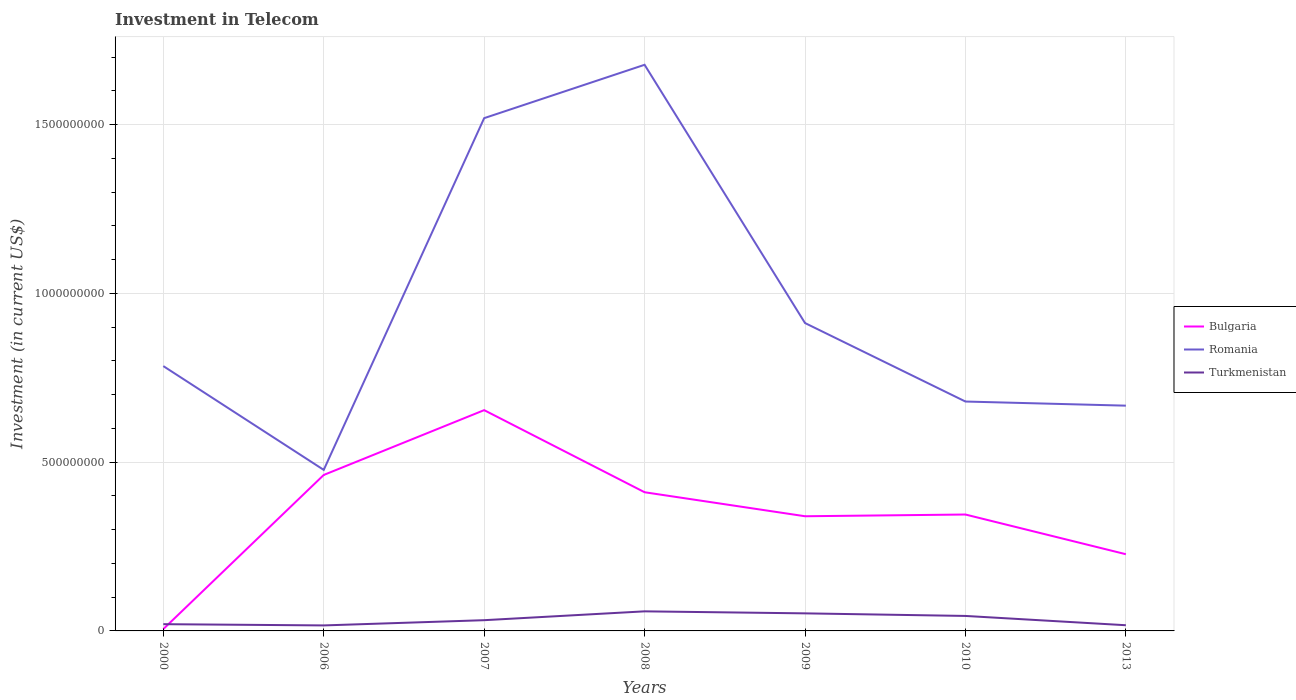How many different coloured lines are there?
Provide a short and direct response. 3. Does the line corresponding to Bulgaria intersect with the line corresponding to Turkmenistan?
Your answer should be very brief. Yes. Across all years, what is the maximum amount invested in telecom in Romania?
Offer a terse response. 4.77e+08. In which year was the amount invested in telecom in Turkmenistan maximum?
Ensure brevity in your answer.  2006. What is the total amount invested in telecom in Bulgaria in the graph?
Give a very brief answer. 6.60e+07. What is the difference between the highest and the second highest amount invested in telecom in Romania?
Make the answer very short. 1.20e+09. What is the difference between the highest and the lowest amount invested in telecom in Turkmenistan?
Your answer should be very brief. 3. What is the difference between two consecutive major ticks on the Y-axis?
Give a very brief answer. 5.00e+08. Does the graph contain grids?
Offer a terse response. Yes. Where does the legend appear in the graph?
Give a very brief answer. Center right. How many legend labels are there?
Offer a terse response. 3. What is the title of the graph?
Your answer should be very brief. Investment in Telecom. What is the label or title of the Y-axis?
Provide a succinct answer. Investment (in current US$). What is the Investment (in current US$) in Bulgaria in 2000?
Your answer should be compact. 5.40e+06. What is the Investment (in current US$) of Romania in 2000?
Provide a short and direct response. 7.84e+08. What is the Investment (in current US$) in Bulgaria in 2006?
Your answer should be compact. 4.62e+08. What is the Investment (in current US$) in Romania in 2006?
Make the answer very short. 4.77e+08. What is the Investment (in current US$) in Turkmenistan in 2006?
Keep it short and to the point. 1.63e+07. What is the Investment (in current US$) of Bulgaria in 2007?
Provide a succinct answer. 6.54e+08. What is the Investment (in current US$) of Romania in 2007?
Your response must be concise. 1.52e+09. What is the Investment (in current US$) of Turkmenistan in 2007?
Give a very brief answer. 3.18e+07. What is the Investment (in current US$) in Bulgaria in 2008?
Offer a terse response. 4.11e+08. What is the Investment (in current US$) of Romania in 2008?
Give a very brief answer. 1.68e+09. What is the Investment (in current US$) in Turkmenistan in 2008?
Provide a succinct answer. 5.80e+07. What is the Investment (in current US$) of Bulgaria in 2009?
Give a very brief answer. 3.40e+08. What is the Investment (in current US$) in Romania in 2009?
Give a very brief answer. 9.12e+08. What is the Investment (in current US$) in Turkmenistan in 2009?
Offer a terse response. 5.20e+07. What is the Investment (in current US$) of Bulgaria in 2010?
Ensure brevity in your answer.  3.45e+08. What is the Investment (in current US$) of Romania in 2010?
Ensure brevity in your answer.  6.80e+08. What is the Investment (in current US$) of Turkmenistan in 2010?
Offer a terse response. 4.44e+07. What is the Investment (in current US$) of Bulgaria in 2013?
Give a very brief answer. 2.27e+08. What is the Investment (in current US$) in Romania in 2013?
Provide a succinct answer. 6.67e+08. What is the Investment (in current US$) in Turkmenistan in 2013?
Your answer should be compact. 1.69e+07. Across all years, what is the maximum Investment (in current US$) in Bulgaria?
Your answer should be compact. 6.54e+08. Across all years, what is the maximum Investment (in current US$) of Romania?
Provide a succinct answer. 1.68e+09. Across all years, what is the maximum Investment (in current US$) of Turkmenistan?
Ensure brevity in your answer.  5.80e+07. Across all years, what is the minimum Investment (in current US$) of Bulgaria?
Your answer should be compact. 5.40e+06. Across all years, what is the minimum Investment (in current US$) of Romania?
Ensure brevity in your answer.  4.77e+08. Across all years, what is the minimum Investment (in current US$) of Turkmenistan?
Offer a terse response. 1.63e+07. What is the total Investment (in current US$) of Bulgaria in the graph?
Provide a short and direct response. 2.44e+09. What is the total Investment (in current US$) in Romania in the graph?
Keep it short and to the point. 6.72e+09. What is the total Investment (in current US$) in Turkmenistan in the graph?
Give a very brief answer. 2.39e+08. What is the difference between the Investment (in current US$) in Bulgaria in 2000 and that in 2006?
Your answer should be compact. -4.57e+08. What is the difference between the Investment (in current US$) in Romania in 2000 and that in 2006?
Ensure brevity in your answer.  3.08e+08. What is the difference between the Investment (in current US$) of Turkmenistan in 2000 and that in 2006?
Your answer should be very brief. 3.70e+06. What is the difference between the Investment (in current US$) in Bulgaria in 2000 and that in 2007?
Your response must be concise. -6.49e+08. What is the difference between the Investment (in current US$) in Romania in 2000 and that in 2007?
Your response must be concise. -7.34e+08. What is the difference between the Investment (in current US$) in Turkmenistan in 2000 and that in 2007?
Ensure brevity in your answer.  -1.18e+07. What is the difference between the Investment (in current US$) of Bulgaria in 2000 and that in 2008?
Offer a very short reply. -4.05e+08. What is the difference between the Investment (in current US$) in Romania in 2000 and that in 2008?
Your response must be concise. -8.92e+08. What is the difference between the Investment (in current US$) of Turkmenistan in 2000 and that in 2008?
Give a very brief answer. -3.80e+07. What is the difference between the Investment (in current US$) in Bulgaria in 2000 and that in 2009?
Give a very brief answer. -3.34e+08. What is the difference between the Investment (in current US$) of Romania in 2000 and that in 2009?
Give a very brief answer. -1.28e+08. What is the difference between the Investment (in current US$) of Turkmenistan in 2000 and that in 2009?
Make the answer very short. -3.20e+07. What is the difference between the Investment (in current US$) of Bulgaria in 2000 and that in 2010?
Ensure brevity in your answer.  -3.39e+08. What is the difference between the Investment (in current US$) in Romania in 2000 and that in 2010?
Your answer should be compact. 1.05e+08. What is the difference between the Investment (in current US$) of Turkmenistan in 2000 and that in 2010?
Keep it short and to the point. -2.44e+07. What is the difference between the Investment (in current US$) of Bulgaria in 2000 and that in 2013?
Offer a very short reply. -2.22e+08. What is the difference between the Investment (in current US$) in Romania in 2000 and that in 2013?
Your response must be concise. 1.17e+08. What is the difference between the Investment (in current US$) of Turkmenistan in 2000 and that in 2013?
Give a very brief answer. 3.13e+06. What is the difference between the Investment (in current US$) of Bulgaria in 2006 and that in 2007?
Keep it short and to the point. -1.92e+08. What is the difference between the Investment (in current US$) of Romania in 2006 and that in 2007?
Give a very brief answer. -1.04e+09. What is the difference between the Investment (in current US$) of Turkmenistan in 2006 and that in 2007?
Your answer should be very brief. -1.55e+07. What is the difference between the Investment (in current US$) of Bulgaria in 2006 and that in 2008?
Give a very brief answer. 5.12e+07. What is the difference between the Investment (in current US$) of Romania in 2006 and that in 2008?
Ensure brevity in your answer.  -1.20e+09. What is the difference between the Investment (in current US$) of Turkmenistan in 2006 and that in 2008?
Offer a terse response. -4.17e+07. What is the difference between the Investment (in current US$) of Bulgaria in 2006 and that in 2009?
Give a very brief answer. 1.22e+08. What is the difference between the Investment (in current US$) of Romania in 2006 and that in 2009?
Provide a short and direct response. -4.35e+08. What is the difference between the Investment (in current US$) of Turkmenistan in 2006 and that in 2009?
Your answer should be compact. -3.57e+07. What is the difference between the Investment (in current US$) in Bulgaria in 2006 and that in 2010?
Provide a succinct answer. 1.17e+08. What is the difference between the Investment (in current US$) of Romania in 2006 and that in 2010?
Provide a succinct answer. -2.02e+08. What is the difference between the Investment (in current US$) in Turkmenistan in 2006 and that in 2010?
Keep it short and to the point. -2.81e+07. What is the difference between the Investment (in current US$) of Bulgaria in 2006 and that in 2013?
Keep it short and to the point. 2.35e+08. What is the difference between the Investment (in current US$) of Romania in 2006 and that in 2013?
Your answer should be very brief. -1.90e+08. What is the difference between the Investment (in current US$) of Turkmenistan in 2006 and that in 2013?
Ensure brevity in your answer.  -5.70e+05. What is the difference between the Investment (in current US$) of Bulgaria in 2007 and that in 2008?
Your response must be concise. 2.43e+08. What is the difference between the Investment (in current US$) of Romania in 2007 and that in 2008?
Make the answer very short. -1.58e+08. What is the difference between the Investment (in current US$) in Turkmenistan in 2007 and that in 2008?
Offer a terse response. -2.62e+07. What is the difference between the Investment (in current US$) in Bulgaria in 2007 and that in 2009?
Your response must be concise. 3.14e+08. What is the difference between the Investment (in current US$) in Romania in 2007 and that in 2009?
Provide a succinct answer. 6.07e+08. What is the difference between the Investment (in current US$) in Turkmenistan in 2007 and that in 2009?
Provide a succinct answer. -2.02e+07. What is the difference between the Investment (in current US$) of Bulgaria in 2007 and that in 2010?
Your answer should be very brief. 3.09e+08. What is the difference between the Investment (in current US$) in Romania in 2007 and that in 2010?
Keep it short and to the point. 8.39e+08. What is the difference between the Investment (in current US$) in Turkmenistan in 2007 and that in 2010?
Your response must be concise. -1.26e+07. What is the difference between the Investment (in current US$) in Bulgaria in 2007 and that in 2013?
Your response must be concise. 4.27e+08. What is the difference between the Investment (in current US$) in Romania in 2007 and that in 2013?
Offer a very short reply. 8.52e+08. What is the difference between the Investment (in current US$) in Turkmenistan in 2007 and that in 2013?
Give a very brief answer. 1.49e+07. What is the difference between the Investment (in current US$) of Bulgaria in 2008 and that in 2009?
Your response must be concise. 7.11e+07. What is the difference between the Investment (in current US$) of Romania in 2008 and that in 2009?
Your answer should be very brief. 7.65e+08. What is the difference between the Investment (in current US$) in Turkmenistan in 2008 and that in 2009?
Keep it short and to the point. 6.00e+06. What is the difference between the Investment (in current US$) of Bulgaria in 2008 and that in 2010?
Give a very brief answer. 6.60e+07. What is the difference between the Investment (in current US$) of Romania in 2008 and that in 2010?
Keep it short and to the point. 9.98e+08. What is the difference between the Investment (in current US$) of Turkmenistan in 2008 and that in 2010?
Your answer should be compact. 1.36e+07. What is the difference between the Investment (in current US$) of Bulgaria in 2008 and that in 2013?
Make the answer very short. 1.84e+08. What is the difference between the Investment (in current US$) in Romania in 2008 and that in 2013?
Your response must be concise. 1.01e+09. What is the difference between the Investment (in current US$) of Turkmenistan in 2008 and that in 2013?
Your answer should be compact. 4.11e+07. What is the difference between the Investment (in current US$) of Bulgaria in 2009 and that in 2010?
Provide a succinct answer. -5.10e+06. What is the difference between the Investment (in current US$) of Romania in 2009 and that in 2010?
Ensure brevity in your answer.  2.32e+08. What is the difference between the Investment (in current US$) in Turkmenistan in 2009 and that in 2010?
Your answer should be very brief. 7.60e+06. What is the difference between the Investment (in current US$) of Bulgaria in 2009 and that in 2013?
Your response must be concise. 1.12e+08. What is the difference between the Investment (in current US$) in Romania in 2009 and that in 2013?
Your response must be concise. 2.45e+08. What is the difference between the Investment (in current US$) in Turkmenistan in 2009 and that in 2013?
Give a very brief answer. 3.51e+07. What is the difference between the Investment (in current US$) in Bulgaria in 2010 and that in 2013?
Offer a very short reply. 1.18e+08. What is the difference between the Investment (in current US$) in Romania in 2010 and that in 2013?
Provide a succinct answer. 1.22e+07. What is the difference between the Investment (in current US$) of Turkmenistan in 2010 and that in 2013?
Offer a very short reply. 2.75e+07. What is the difference between the Investment (in current US$) in Bulgaria in 2000 and the Investment (in current US$) in Romania in 2006?
Make the answer very short. -4.72e+08. What is the difference between the Investment (in current US$) of Bulgaria in 2000 and the Investment (in current US$) of Turkmenistan in 2006?
Provide a short and direct response. -1.09e+07. What is the difference between the Investment (in current US$) in Romania in 2000 and the Investment (in current US$) in Turkmenistan in 2006?
Provide a succinct answer. 7.68e+08. What is the difference between the Investment (in current US$) in Bulgaria in 2000 and the Investment (in current US$) in Romania in 2007?
Your answer should be very brief. -1.51e+09. What is the difference between the Investment (in current US$) in Bulgaria in 2000 and the Investment (in current US$) in Turkmenistan in 2007?
Make the answer very short. -2.64e+07. What is the difference between the Investment (in current US$) of Romania in 2000 and the Investment (in current US$) of Turkmenistan in 2007?
Your answer should be very brief. 7.53e+08. What is the difference between the Investment (in current US$) of Bulgaria in 2000 and the Investment (in current US$) of Romania in 2008?
Keep it short and to the point. -1.67e+09. What is the difference between the Investment (in current US$) of Bulgaria in 2000 and the Investment (in current US$) of Turkmenistan in 2008?
Provide a succinct answer. -5.26e+07. What is the difference between the Investment (in current US$) of Romania in 2000 and the Investment (in current US$) of Turkmenistan in 2008?
Offer a very short reply. 7.26e+08. What is the difference between the Investment (in current US$) of Bulgaria in 2000 and the Investment (in current US$) of Romania in 2009?
Your answer should be very brief. -9.07e+08. What is the difference between the Investment (in current US$) in Bulgaria in 2000 and the Investment (in current US$) in Turkmenistan in 2009?
Make the answer very short. -4.66e+07. What is the difference between the Investment (in current US$) in Romania in 2000 and the Investment (in current US$) in Turkmenistan in 2009?
Make the answer very short. 7.32e+08. What is the difference between the Investment (in current US$) in Bulgaria in 2000 and the Investment (in current US$) in Romania in 2010?
Give a very brief answer. -6.74e+08. What is the difference between the Investment (in current US$) of Bulgaria in 2000 and the Investment (in current US$) of Turkmenistan in 2010?
Your answer should be very brief. -3.90e+07. What is the difference between the Investment (in current US$) in Romania in 2000 and the Investment (in current US$) in Turkmenistan in 2010?
Keep it short and to the point. 7.40e+08. What is the difference between the Investment (in current US$) in Bulgaria in 2000 and the Investment (in current US$) in Romania in 2013?
Offer a terse response. -6.62e+08. What is the difference between the Investment (in current US$) of Bulgaria in 2000 and the Investment (in current US$) of Turkmenistan in 2013?
Offer a very short reply. -1.15e+07. What is the difference between the Investment (in current US$) of Romania in 2000 and the Investment (in current US$) of Turkmenistan in 2013?
Make the answer very short. 7.68e+08. What is the difference between the Investment (in current US$) of Bulgaria in 2006 and the Investment (in current US$) of Romania in 2007?
Your answer should be very brief. -1.06e+09. What is the difference between the Investment (in current US$) in Bulgaria in 2006 and the Investment (in current US$) in Turkmenistan in 2007?
Provide a succinct answer. 4.30e+08. What is the difference between the Investment (in current US$) of Romania in 2006 and the Investment (in current US$) of Turkmenistan in 2007?
Provide a short and direct response. 4.45e+08. What is the difference between the Investment (in current US$) in Bulgaria in 2006 and the Investment (in current US$) in Romania in 2008?
Offer a terse response. -1.22e+09. What is the difference between the Investment (in current US$) in Bulgaria in 2006 and the Investment (in current US$) in Turkmenistan in 2008?
Your answer should be very brief. 4.04e+08. What is the difference between the Investment (in current US$) in Romania in 2006 and the Investment (in current US$) in Turkmenistan in 2008?
Your answer should be compact. 4.19e+08. What is the difference between the Investment (in current US$) of Bulgaria in 2006 and the Investment (in current US$) of Romania in 2009?
Give a very brief answer. -4.50e+08. What is the difference between the Investment (in current US$) of Bulgaria in 2006 and the Investment (in current US$) of Turkmenistan in 2009?
Offer a very short reply. 4.10e+08. What is the difference between the Investment (in current US$) in Romania in 2006 and the Investment (in current US$) in Turkmenistan in 2009?
Give a very brief answer. 4.25e+08. What is the difference between the Investment (in current US$) of Bulgaria in 2006 and the Investment (in current US$) of Romania in 2010?
Provide a succinct answer. -2.18e+08. What is the difference between the Investment (in current US$) of Bulgaria in 2006 and the Investment (in current US$) of Turkmenistan in 2010?
Provide a short and direct response. 4.18e+08. What is the difference between the Investment (in current US$) in Romania in 2006 and the Investment (in current US$) in Turkmenistan in 2010?
Keep it short and to the point. 4.33e+08. What is the difference between the Investment (in current US$) of Bulgaria in 2006 and the Investment (in current US$) of Romania in 2013?
Offer a very short reply. -2.05e+08. What is the difference between the Investment (in current US$) of Bulgaria in 2006 and the Investment (in current US$) of Turkmenistan in 2013?
Offer a terse response. 4.45e+08. What is the difference between the Investment (in current US$) in Romania in 2006 and the Investment (in current US$) in Turkmenistan in 2013?
Offer a very short reply. 4.60e+08. What is the difference between the Investment (in current US$) of Bulgaria in 2007 and the Investment (in current US$) of Romania in 2008?
Your answer should be very brief. -1.02e+09. What is the difference between the Investment (in current US$) of Bulgaria in 2007 and the Investment (in current US$) of Turkmenistan in 2008?
Ensure brevity in your answer.  5.96e+08. What is the difference between the Investment (in current US$) of Romania in 2007 and the Investment (in current US$) of Turkmenistan in 2008?
Offer a terse response. 1.46e+09. What is the difference between the Investment (in current US$) of Bulgaria in 2007 and the Investment (in current US$) of Romania in 2009?
Offer a very short reply. -2.58e+08. What is the difference between the Investment (in current US$) of Bulgaria in 2007 and the Investment (in current US$) of Turkmenistan in 2009?
Your response must be concise. 6.02e+08. What is the difference between the Investment (in current US$) of Romania in 2007 and the Investment (in current US$) of Turkmenistan in 2009?
Provide a short and direct response. 1.47e+09. What is the difference between the Investment (in current US$) of Bulgaria in 2007 and the Investment (in current US$) of Romania in 2010?
Your answer should be very brief. -2.55e+07. What is the difference between the Investment (in current US$) of Bulgaria in 2007 and the Investment (in current US$) of Turkmenistan in 2010?
Offer a terse response. 6.10e+08. What is the difference between the Investment (in current US$) in Romania in 2007 and the Investment (in current US$) in Turkmenistan in 2010?
Make the answer very short. 1.47e+09. What is the difference between the Investment (in current US$) in Bulgaria in 2007 and the Investment (in current US$) in Romania in 2013?
Offer a very short reply. -1.33e+07. What is the difference between the Investment (in current US$) of Bulgaria in 2007 and the Investment (in current US$) of Turkmenistan in 2013?
Ensure brevity in your answer.  6.37e+08. What is the difference between the Investment (in current US$) in Romania in 2007 and the Investment (in current US$) in Turkmenistan in 2013?
Your response must be concise. 1.50e+09. What is the difference between the Investment (in current US$) of Bulgaria in 2008 and the Investment (in current US$) of Romania in 2009?
Ensure brevity in your answer.  -5.01e+08. What is the difference between the Investment (in current US$) in Bulgaria in 2008 and the Investment (in current US$) in Turkmenistan in 2009?
Provide a short and direct response. 3.59e+08. What is the difference between the Investment (in current US$) in Romania in 2008 and the Investment (in current US$) in Turkmenistan in 2009?
Offer a very short reply. 1.62e+09. What is the difference between the Investment (in current US$) in Bulgaria in 2008 and the Investment (in current US$) in Romania in 2010?
Provide a short and direct response. -2.69e+08. What is the difference between the Investment (in current US$) in Bulgaria in 2008 and the Investment (in current US$) in Turkmenistan in 2010?
Keep it short and to the point. 3.66e+08. What is the difference between the Investment (in current US$) of Romania in 2008 and the Investment (in current US$) of Turkmenistan in 2010?
Keep it short and to the point. 1.63e+09. What is the difference between the Investment (in current US$) of Bulgaria in 2008 and the Investment (in current US$) of Romania in 2013?
Give a very brief answer. -2.56e+08. What is the difference between the Investment (in current US$) of Bulgaria in 2008 and the Investment (in current US$) of Turkmenistan in 2013?
Provide a succinct answer. 3.94e+08. What is the difference between the Investment (in current US$) in Romania in 2008 and the Investment (in current US$) in Turkmenistan in 2013?
Provide a succinct answer. 1.66e+09. What is the difference between the Investment (in current US$) of Bulgaria in 2009 and the Investment (in current US$) of Romania in 2010?
Ensure brevity in your answer.  -3.40e+08. What is the difference between the Investment (in current US$) of Bulgaria in 2009 and the Investment (in current US$) of Turkmenistan in 2010?
Keep it short and to the point. 2.95e+08. What is the difference between the Investment (in current US$) in Romania in 2009 and the Investment (in current US$) in Turkmenistan in 2010?
Provide a succinct answer. 8.68e+08. What is the difference between the Investment (in current US$) in Bulgaria in 2009 and the Investment (in current US$) in Romania in 2013?
Your answer should be compact. -3.28e+08. What is the difference between the Investment (in current US$) of Bulgaria in 2009 and the Investment (in current US$) of Turkmenistan in 2013?
Make the answer very short. 3.23e+08. What is the difference between the Investment (in current US$) in Romania in 2009 and the Investment (in current US$) in Turkmenistan in 2013?
Make the answer very short. 8.95e+08. What is the difference between the Investment (in current US$) of Bulgaria in 2010 and the Investment (in current US$) of Romania in 2013?
Make the answer very short. -3.22e+08. What is the difference between the Investment (in current US$) in Bulgaria in 2010 and the Investment (in current US$) in Turkmenistan in 2013?
Offer a terse response. 3.28e+08. What is the difference between the Investment (in current US$) of Romania in 2010 and the Investment (in current US$) of Turkmenistan in 2013?
Your answer should be compact. 6.63e+08. What is the average Investment (in current US$) in Bulgaria per year?
Give a very brief answer. 3.49e+08. What is the average Investment (in current US$) of Romania per year?
Keep it short and to the point. 9.59e+08. What is the average Investment (in current US$) of Turkmenistan per year?
Make the answer very short. 3.42e+07. In the year 2000, what is the difference between the Investment (in current US$) in Bulgaria and Investment (in current US$) in Romania?
Keep it short and to the point. -7.79e+08. In the year 2000, what is the difference between the Investment (in current US$) in Bulgaria and Investment (in current US$) in Turkmenistan?
Your answer should be compact. -1.46e+07. In the year 2000, what is the difference between the Investment (in current US$) in Romania and Investment (in current US$) in Turkmenistan?
Your answer should be very brief. 7.64e+08. In the year 2006, what is the difference between the Investment (in current US$) of Bulgaria and Investment (in current US$) of Romania?
Your answer should be very brief. -1.50e+07. In the year 2006, what is the difference between the Investment (in current US$) of Bulgaria and Investment (in current US$) of Turkmenistan?
Make the answer very short. 4.46e+08. In the year 2006, what is the difference between the Investment (in current US$) in Romania and Investment (in current US$) in Turkmenistan?
Provide a short and direct response. 4.61e+08. In the year 2007, what is the difference between the Investment (in current US$) in Bulgaria and Investment (in current US$) in Romania?
Offer a very short reply. -8.65e+08. In the year 2007, what is the difference between the Investment (in current US$) of Bulgaria and Investment (in current US$) of Turkmenistan?
Provide a succinct answer. 6.22e+08. In the year 2007, what is the difference between the Investment (in current US$) in Romania and Investment (in current US$) in Turkmenistan?
Your answer should be very brief. 1.49e+09. In the year 2008, what is the difference between the Investment (in current US$) of Bulgaria and Investment (in current US$) of Romania?
Your answer should be very brief. -1.27e+09. In the year 2008, what is the difference between the Investment (in current US$) in Bulgaria and Investment (in current US$) in Turkmenistan?
Offer a very short reply. 3.53e+08. In the year 2008, what is the difference between the Investment (in current US$) in Romania and Investment (in current US$) in Turkmenistan?
Provide a short and direct response. 1.62e+09. In the year 2009, what is the difference between the Investment (in current US$) in Bulgaria and Investment (in current US$) in Romania?
Your response must be concise. -5.72e+08. In the year 2009, what is the difference between the Investment (in current US$) of Bulgaria and Investment (in current US$) of Turkmenistan?
Your response must be concise. 2.88e+08. In the year 2009, what is the difference between the Investment (in current US$) of Romania and Investment (in current US$) of Turkmenistan?
Make the answer very short. 8.60e+08. In the year 2010, what is the difference between the Investment (in current US$) of Bulgaria and Investment (in current US$) of Romania?
Offer a terse response. -3.35e+08. In the year 2010, what is the difference between the Investment (in current US$) in Bulgaria and Investment (in current US$) in Turkmenistan?
Keep it short and to the point. 3.00e+08. In the year 2010, what is the difference between the Investment (in current US$) of Romania and Investment (in current US$) of Turkmenistan?
Your answer should be very brief. 6.35e+08. In the year 2013, what is the difference between the Investment (in current US$) in Bulgaria and Investment (in current US$) in Romania?
Make the answer very short. -4.40e+08. In the year 2013, what is the difference between the Investment (in current US$) in Bulgaria and Investment (in current US$) in Turkmenistan?
Keep it short and to the point. 2.10e+08. In the year 2013, what is the difference between the Investment (in current US$) in Romania and Investment (in current US$) in Turkmenistan?
Ensure brevity in your answer.  6.50e+08. What is the ratio of the Investment (in current US$) in Bulgaria in 2000 to that in 2006?
Your response must be concise. 0.01. What is the ratio of the Investment (in current US$) in Romania in 2000 to that in 2006?
Your answer should be very brief. 1.64. What is the ratio of the Investment (in current US$) in Turkmenistan in 2000 to that in 2006?
Offer a terse response. 1.23. What is the ratio of the Investment (in current US$) of Bulgaria in 2000 to that in 2007?
Your answer should be very brief. 0.01. What is the ratio of the Investment (in current US$) of Romania in 2000 to that in 2007?
Your answer should be very brief. 0.52. What is the ratio of the Investment (in current US$) in Turkmenistan in 2000 to that in 2007?
Ensure brevity in your answer.  0.63. What is the ratio of the Investment (in current US$) of Bulgaria in 2000 to that in 2008?
Your answer should be compact. 0.01. What is the ratio of the Investment (in current US$) in Romania in 2000 to that in 2008?
Offer a very short reply. 0.47. What is the ratio of the Investment (in current US$) in Turkmenistan in 2000 to that in 2008?
Your response must be concise. 0.34. What is the ratio of the Investment (in current US$) in Bulgaria in 2000 to that in 2009?
Provide a succinct answer. 0.02. What is the ratio of the Investment (in current US$) in Romania in 2000 to that in 2009?
Provide a short and direct response. 0.86. What is the ratio of the Investment (in current US$) of Turkmenistan in 2000 to that in 2009?
Offer a very short reply. 0.38. What is the ratio of the Investment (in current US$) of Bulgaria in 2000 to that in 2010?
Provide a short and direct response. 0.02. What is the ratio of the Investment (in current US$) of Romania in 2000 to that in 2010?
Provide a succinct answer. 1.15. What is the ratio of the Investment (in current US$) of Turkmenistan in 2000 to that in 2010?
Your answer should be compact. 0.45. What is the ratio of the Investment (in current US$) in Bulgaria in 2000 to that in 2013?
Offer a very short reply. 0.02. What is the ratio of the Investment (in current US$) in Romania in 2000 to that in 2013?
Provide a short and direct response. 1.18. What is the ratio of the Investment (in current US$) in Turkmenistan in 2000 to that in 2013?
Provide a succinct answer. 1.19. What is the ratio of the Investment (in current US$) of Bulgaria in 2006 to that in 2007?
Your answer should be very brief. 0.71. What is the ratio of the Investment (in current US$) of Romania in 2006 to that in 2007?
Offer a very short reply. 0.31. What is the ratio of the Investment (in current US$) in Turkmenistan in 2006 to that in 2007?
Keep it short and to the point. 0.51. What is the ratio of the Investment (in current US$) of Bulgaria in 2006 to that in 2008?
Provide a succinct answer. 1.12. What is the ratio of the Investment (in current US$) of Romania in 2006 to that in 2008?
Provide a short and direct response. 0.28. What is the ratio of the Investment (in current US$) of Turkmenistan in 2006 to that in 2008?
Make the answer very short. 0.28. What is the ratio of the Investment (in current US$) in Bulgaria in 2006 to that in 2009?
Ensure brevity in your answer.  1.36. What is the ratio of the Investment (in current US$) in Romania in 2006 to that in 2009?
Provide a short and direct response. 0.52. What is the ratio of the Investment (in current US$) of Turkmenistan in 2006 to that in 2009?
Your answer should be very brief. 0.31. What is the ratio of the Investment (in current US$) in Bulgaria in 2006 to that in 2010?
Offer a terse response. 1.34. What is the ratio of the Investment (in current US$) in Romania in 2006 to that in 2010?
Provide a short and direct response. 0.7. What is the ratio of the Investment (in current US$) of Turkmenistan in 2006 to that in 2010?
Your answer should be very brief. 0.37. What is the ratio of the Investment (in current US$) of Bulgaria in 2006 to that in 2013?
Keep it short and to the point. 2.03. What is the ratio of the Investment (in current US$) in Romania in 2006 to that in 2013?
Offer a very short reply. 0.71. What is the ratio of the Investment (in current US$) in Turkmenistan in 2006 to that in 2013?
Your answer should be compact. 0.97. What is the ratio of the Investment (in current US$) in Bulgaria in 2007 to that in 2008?
Your answer should be compact. 1.59. What is the ratio of the Investment (in current US$) in Romania in 2007 to that in 2008?
Provide a short and direct response. 0.91. What is the ratio of the Investment (in current US$) of Turkmenistan in 2007 to that in 2008?
Your response must be concise. 0.55. What is the ratio of the Investment (in current US$) in Bulgaria in 2007 to that in 2009?
Make the answer very short. 1.93. What is the ratio of the Investment (in current US$) in Romania in 2007 to that in 2009?
Your answer should be compact. 1.67. What is the ratio of the Investment (in current US$) of Turkmenistan in 2007 to that in 2009?
Provide a short and direct response. 0.61. What is the ratio of the Investment (in current US$) in Bulgaria in 2007 to that in 2010?
Your response must be concise. 1.9. What is the ratio of the Investment (in current US$) in Romania in 2007 to that in 2010?
Your response must be concise. 2.24. What is the ratio of the Investment (in current US$) in Turkmenistan in 2007 to that in 2010?
Make the answer very short. 0.72. What is the ratio of the Investment (in current US$) of Bulgaria in 2007 to that in 2013?
Provide a short and direct response. 2.88. What is the ratio of the Investment (in current US$) in Romania in 2007 to that in 2013?
Offer a very short reply. 2.28. What is the ratio of the Investment (in current US$) of Turkmenistan in 2007 to that in 2013?
Your answer should be compact. 1.89. What is the ratio of the Investment (in current US$) of Bulgaria in 2008 to that in 2009?
Provide a succinct answer. 1.21. What is the ratio of the Investment (in current US$) in Romania in 2008 to that in 2009?
Offer a terse response. 1.84. What is the ratio of the Investment (in current US$) in Turkmenistan in 2008 to that in 2009?
Offer a terse response. 1.12. What is the ratio of the Investment (in current US$) of Bulgaria in 2008 to that in 2010?
Your answer should be very brief. 1.19. What is the ratio of the Investment (in current US$) of Romania in 2008 to that in 2010?
Ensure brevity in your answer.  2.47. What is the ratio of the Investment (in current US$) of Turkmenistan in 2008 to that in 2010?
Ensure brevity in your answer.  1.31. What is the ratio of the Investment (in current US$) in Bulgaria in 2008 to that in 2013?
Make the answer very short. 1.81. What is the ratio of the Investment (in current US$) in Romania in 2008 to that in 2013?
Ensure brevity in your answer.  2.51. What is the ratio of the Investment (in current US$) of Turkmenistan in 2008 to that in 2013?
Provide a short and direct response. 3.44. What is the ratio of the Investment (in current US$) in Bulgaria in 2009 to that in 2010?
Your answer should be very brief. 0.99. What is the ratio of the Investment (in current US$) of Romania in 2009 to that in 2010?
Keep it short and to the point. 1.34. What is the ratio of the Investment (in current US$) of Turkmenistan in 2009 to that in 2010?
Ensure brevity in your answer.  1.17. What is the ratio of the Investment (in current US$) of Bulgaria in 2009 to that in 2013?
Ensure brevity in your answer.  1.5. What is the ratio of the Investment (in current US$) of Romania in 2009 to that in 2013?
Offer a terse response. 1.37. What is the ratio of the Investment (in current US$) in Turkmenistan in 2009 to that in 2013?
Offer a terse response. 3.08. What is the ratio of the Investment (in current US$) of Bulgaria in 2010 to that in 2013?
Ensure brevity in your answer.  1.52. What is the ratio of the Investment (in current US$) of Romania in 2010 to that in 2013?
Give a very brief answer. 1.02. What is the ratio of the Investment (in current US$) of Turkmenistan in 2010 to that in 2013?
Your answer should be compact. 2.63. What is the difference between the highest and the second highest Investment (in current US$) in Bulgaria?
Your response must be concise. 1.92e+08. What is the difference between the highest and the second highest Investment (in current US$) of Romania?
Offer a very short reply. 1.58e+08. What is the difference between the highest and the second highest Investment (in current US$) of Turkmenistan?
Provide a short and direct response. 6.00e+06. What is the difference between the highest and the lowest Investment (in current US$) of Bulgaria?
Your answer should be very brief. 6.49e+08. What is the difference between the highest and the lowest Investment (in current US$) in Romania?
Provide a short and direct response. 1.20e+09. What is the difference between the highest and the lowest Investment (in current US$) in Turkmenistan?
Keep it short and to the point. 4.17e+07. 